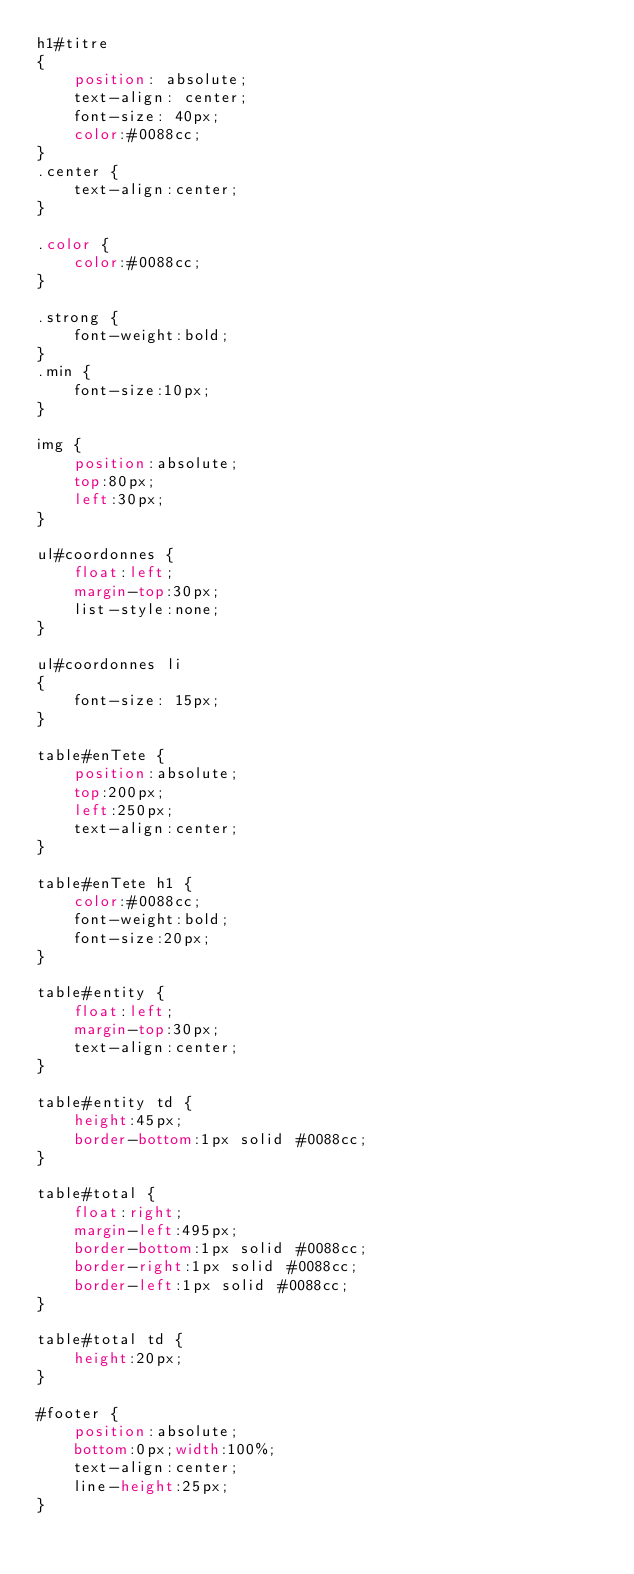Convert code to text. <code><loc_0><loc_0><loc_500><loc_500><_CSS_>h1#titre
{
    position: absolute;
    text-align: center;
    font-size: 40px;
    color:#0088cc;
}
.center {
    text-align:center;
}

.color {
    color:#0088cc;
}

.strong {
    font-weight:bold;
}
.min {
    font-size:10px;
}

img {
    position:absolute;
    top:80px;
    left:30px;
}

ul#coordonnes {
    float:left;
    margin-top:30px;
    list-style:none;
}

ul#coordonnes li
{
    font-size: 15px;
}

table#enTete {
    position:absolute;
    top:200px;
    left:250px;
    text-align:center;
}

table#enTete h1 {
    color:#0088cc;
    font-weight:bold;
    font-size:20px;
}

table#entity {
    float:left;
    margin-top:30px;
    text-align:center;
}

table#entity td {
    height:45px;
    border-bottom:1px solid #0088cc;
}

table#total {
    float:right;
    margin-left:495px;
    border-bottom:1px solid #0088cc;
    border-right:1px solid #0088cc;
    border-left:1px solid #0088cc;
}

table#total td {
    height:20px;
}

#footer {
    position:absolute;
    bottom:0px;width:100%;
    text-align:center;
    line-height:25px;
}</code> 